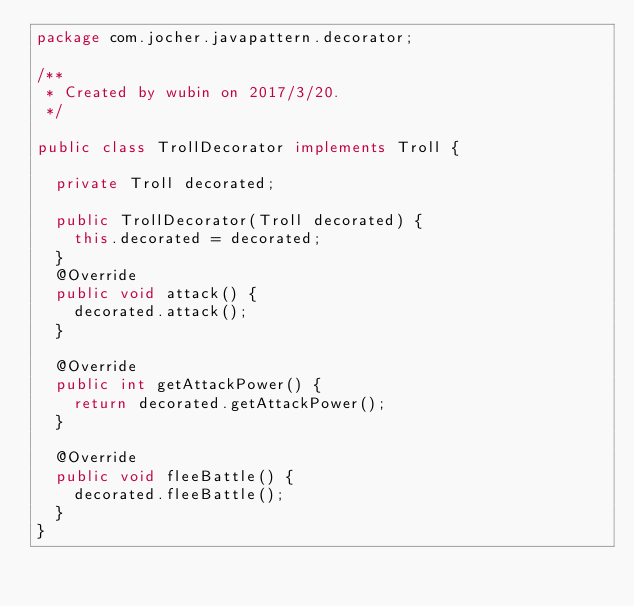<code> <loc_0><loc_0><loc_500><loc_500><_Java_>package com.jocher.javapattern.decorator;

/**
 * Created by wubin on 2017/3/20.
 */

public class TrollDecorator implements Troll {

  private Troll decorated;

  public TrollDecorator(Troll decorated) {
    this.decorated = decorated;
  }
  @Override
  public void attack() {
    decorated.attack();
  }

  @Override
  public int getAttackPower() {
    return decorated.getAttackPower();
  }

  @Override
  public void fleeBattle() {
    decorated.fleeBattle();
  }
}
</code> 